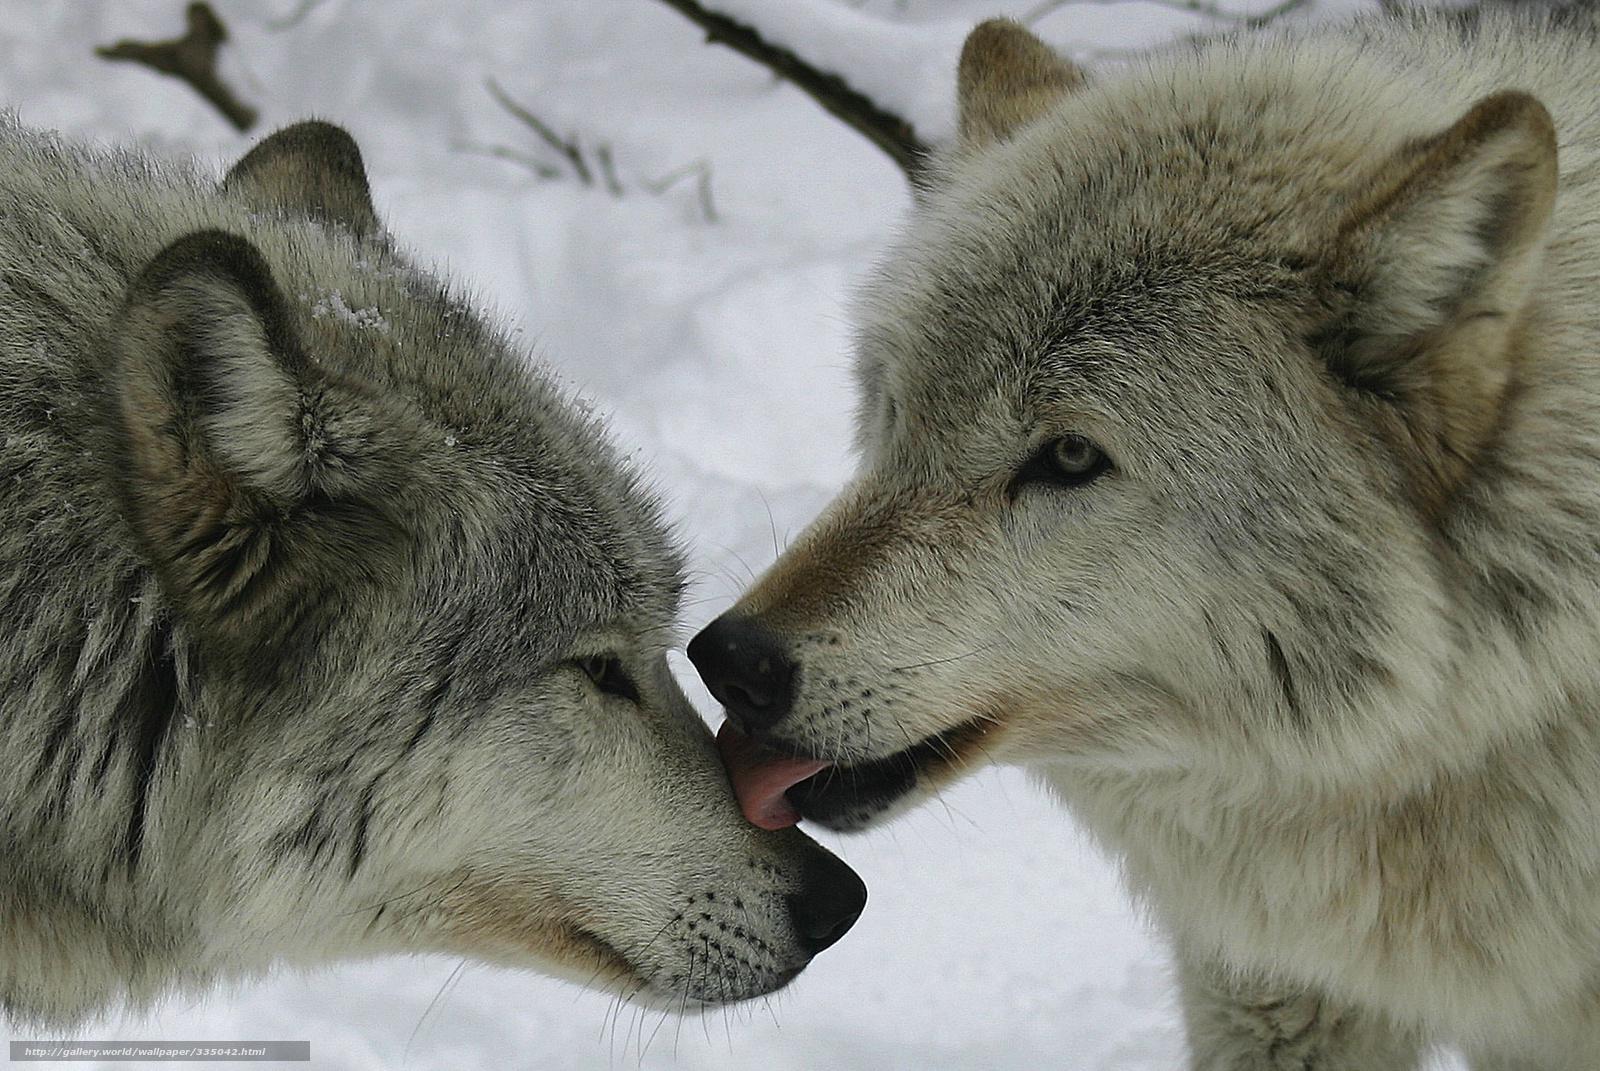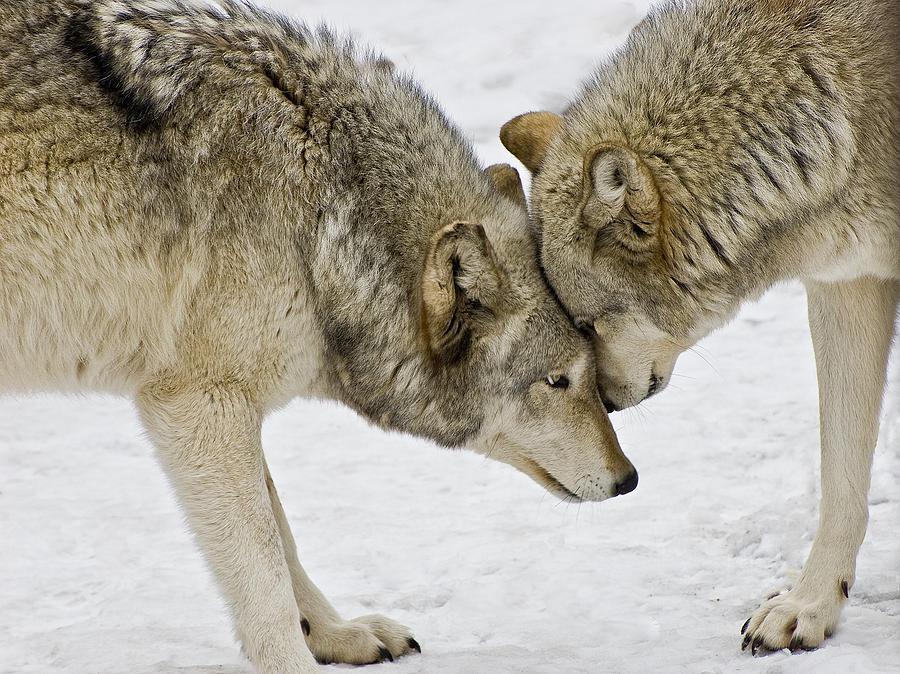The first image is the image on the left, the second image is the image on the right. Analyze the images presented: Is the assertion "All wolves are touching each other's faces in an affectionate way." valid? Answer yes or no. Yes. The first image is the image on the left, the second image is the image on the right. Analyze the images presented: Is the assertion "At least one wolf has its tongue visible in the left image." valid? Answer yes or no. Yes. 